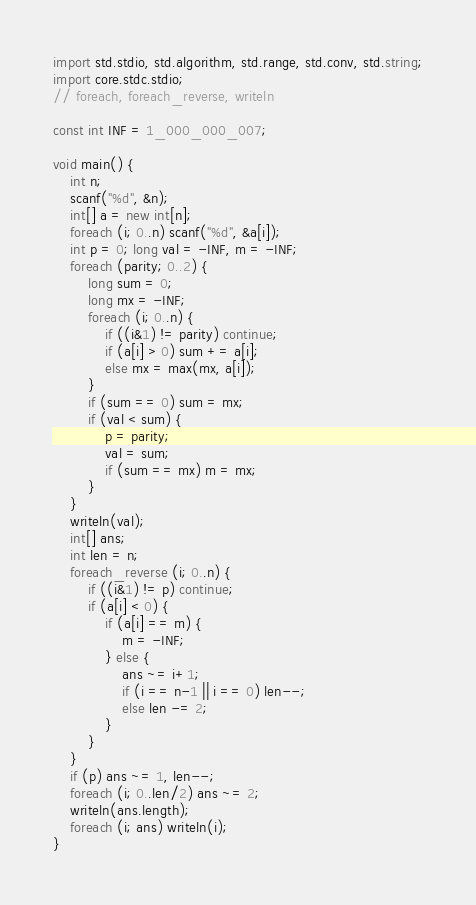Convert code to text. <code><loc_0><loc_0><loc_500><loc_500><_D_>import std.stdio, std.algorithm, std.range, std.conv, std.string;
import core.stdc.stdio;
// foreach, foreach_reverse, writeln

const int INF = 1_000_000_007;

void main() {
	int n;
	scanf("%d", &n);
	int[] a = new int[n];
	foreach (i; 0..n) scanf("%d", &a[i]);
	int p = 0; long val = -INF, m = -INF;
	foreach (parity; 0..2) {
		long sum = 0;
		long mx = -INF;
		foreach (i; 0..n) {
			if ((i&1) != parity) continue;
			if (a[i] > 0) sum += a[i];
			else mx = max(mx, a[i]);
		}
		if (sum == 0) sum = mx;
		if (val < sum) {
			p = parity;
			val = sum;
			if (sum == mx) m = mx;
		}
	}
	writeln(val);
	int[] ans;
	int len = n;
	foreach_reverse (i; 0..n) {
		if ((i&1) != p) continue;
		if (a[i] < 0) {
			if (a[i] == m) {
				m = -INF;
			} else {
				ans ~= i+1;
				if (i == n-1 || i == 0) len--;
				else len -= 2;
			}
		}
	}
	if (p) ans ~= 1, len--;
	foreach (i; 0..len/2) ans ~= 2;
	writeln(ans.length);
	foreach (i; ans) writeln(i);
}

</code> 